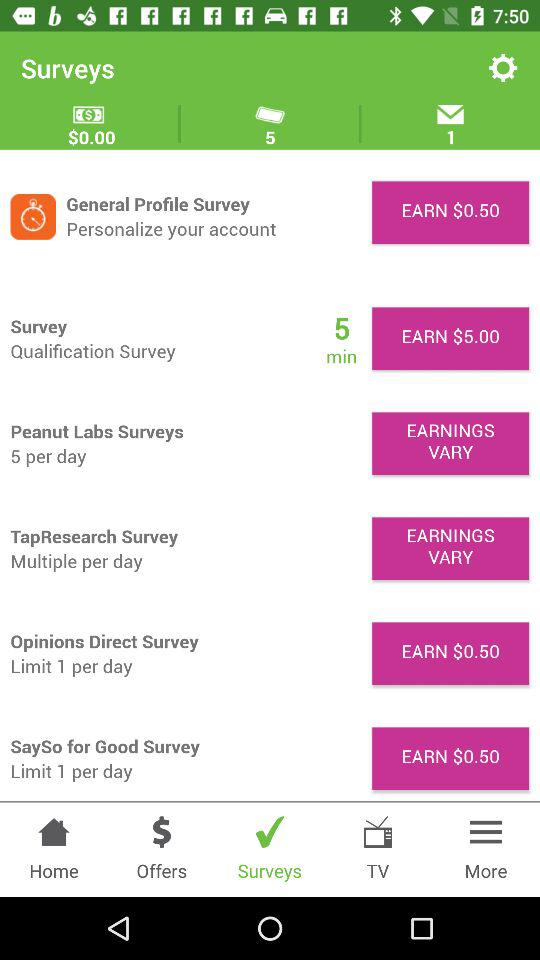How much time does the qualification survey take to complete? The time taken is 5 minutes. 